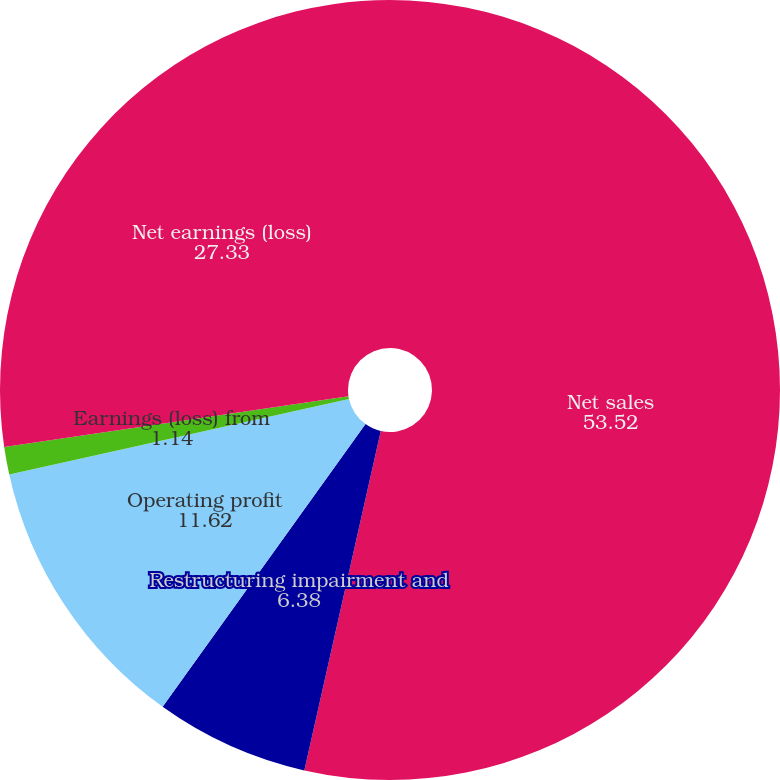<chart> <loc_0><loc_0><loc_500><loc_500><pie_chart><fcel>Net sales<fcel>Restructuring impairment and<fcel>Operating profit<fcel>Earnings (loss) from<fcel>Net earnings (loss)<nl><fcel>53.52%<fcel>6.38%<fcel>11.62%<fcel>1.14%<fcel>27.33%<nl></chart> 